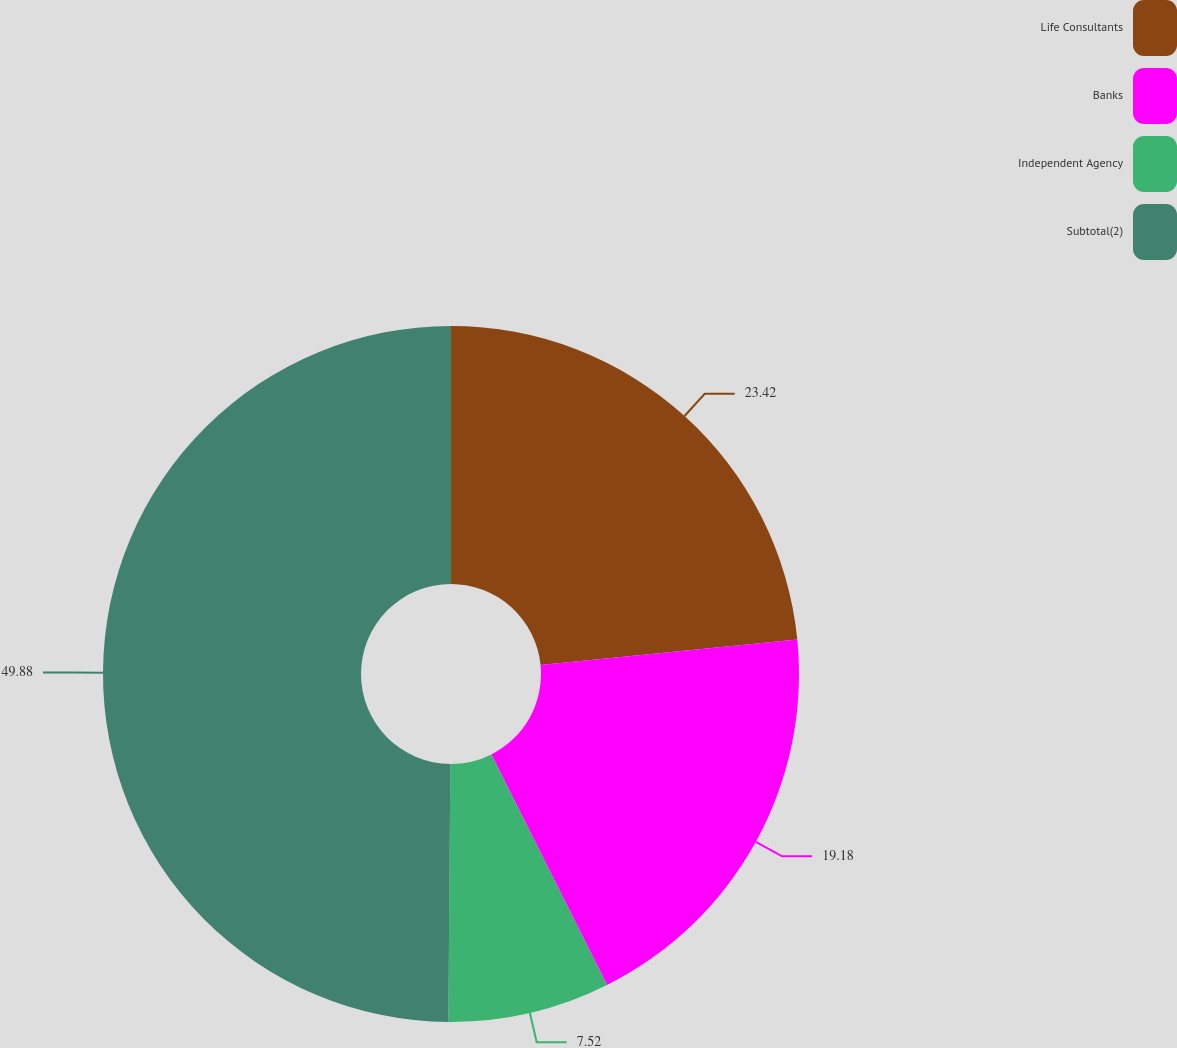Convert chart to OTSL. <chart><loc_0><loc_0><loc_500><loc_500><pie_chart><fcel>Life Consultants<fcel>Banks<fcel>Independent Agency<fcel>Subtotal(2)<nl><fcel>23.42%<fcel>19.18%<fcel>7.52%<fcel>49.88%<nl></chart> 